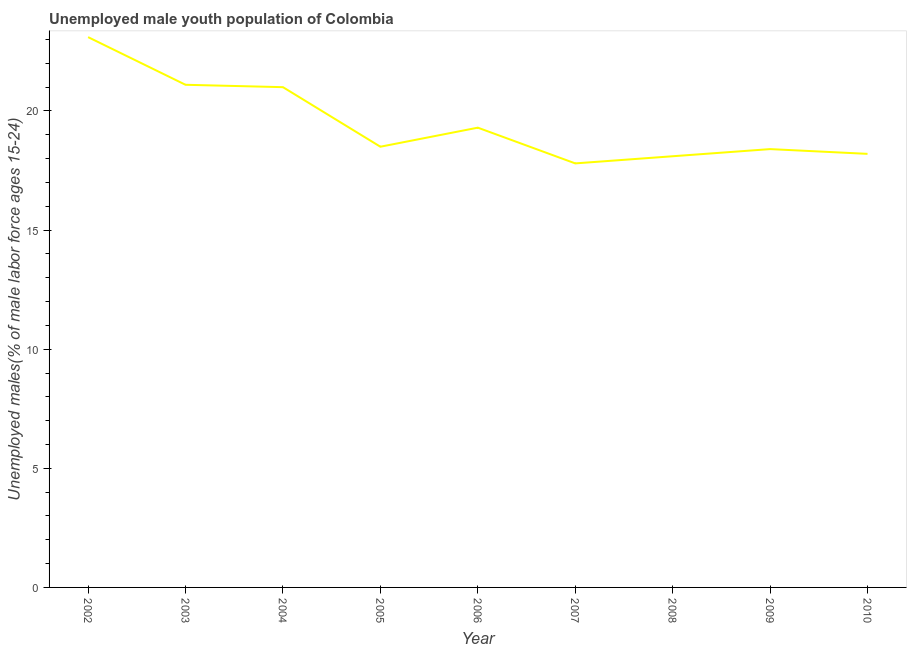What is the unemployed male youth in 2008?
Ensure brevity in your answer.  18.1. Across all years, what is the maximum unemployed male youth?
Provide a succinct answer. 23.1. Across all years, what is the minimum unemployed male youth?
Give a very brief answer. 17.8. In which year was the unemployed male youth maximum?
Make the answer very short. 2002. In which year was the unemployed male youth minimum?
Your answer should be compact. 2007. What is the sum of the unemployed male youth?
Provide a succinct answer. 175.5. What is the difference between the unemployed male youth in 2002 and 2003?
Your answer should be compact. 2. What is the average unemployed male youth per year?
Keep it short and to the point. 19.5. Do a majority of the years between 2006 and 2005 (inclusive) have unemployed male youth greater than 15 %?
Offer a terse response. No. What is the ratio of the unemployed male youth in 2003 to that in 2008?
Give a very brief answer. 1.17. Is the unemployed male youth in 2002 less than that in 2008?
Keep it short and to the point. No. What is the difference between the highest and the second highest unemployed male youth?
Ensure brevity in your answer.  2. What is the difference between the highest and the lowest unemployed male youth?
Provide a succinct answer. 5.3. Does the unemployed male youth monotonically increase over the years?
Your response must be concise. No. How many lines are there?
Give a very brief answer. 1. How many years are there in the graph?
Make the answer very short. 9. Are the values on the major ticks of Y-axis written in scientific E-notation?
Your answer should be very brief. No. Does the graph contain grids?
Your answer should be compact. No. What is the title of the graph?
Your response must be concise. Unemployed male youth population of Colombia. What is the label or title of the Y-axis?
Provide a short and direct response. Unemployed males(% of male labor force ages 15-24). What is the Unemployed males(% of male labor force ages 15-24) in 2002?
Provide a short and direct response. 23.1. What is the Unemployed males(% of male labor force ages 15-24) in 2003?
Offer a very short reply. 21.1. What is the Unemployed males(% of male labor force ages 15-24) of 2004?
Make the answer very short. 21. What is the Unemployed males(% of male labor force ages 15-24) of 2006?
Your answer should be very brief. 19.3. What is the Unemployed males(% of male labor force ages 15-24) of 2007?
Keep it short and to the point. 17.8. What is the Unemployed males(% of male labor force ages 15-24) in 2008?
Offer a terse response. 18.1. What is the Unemployed males(% of male labor force ages 15-24) of 2009?
Provide a succinct answer. 18.4. What is the Unemployed males(% of male labor force ages 15-24) of 2010?
Provide a succinct answer. 18.2. What is the difference between the Unemployed males(% of male labor force ages 15-24) in 2002 and 2004?
Keep it short and to the point. 2.1. What is the difference between the Unemployed males(% of male labor force ages 15-24) in 2002 and 2005?
Your answer should be very brief. 4.6. What is the difference between the Unemployed males(% of male labor force ages 15-24) in 2002 and 2007?
Your answer should be very brief. 5.3. What is the difference between the Unemployed males(% of male labor force ages 15-24) in 2002 and 2010?
Give a very brief answer. 4.9. What is the difference between the Unemployed males(% of male labor force ages 15-24) in 2003 and 2004?
Keep it short and to the point. 0.1. What is the difference between the Unemployed males(% of male labor force ages 15-24) in 2003 and 2005?
Ensure brevity in your answer.  2.6. What is the difference between the Unemployed males(% of male labor force ages 15-24) in 2003 and 2007?
Your response must be concise. 3.3. What is the difference between the Unemployed males(% of male labor force ages 15-24) in 2003 and 2009?
Your answer should be compact. 2.7. What is the difference between the Unemployed males(% of male labor force ages 15-24) in 2003 and 2010?
Offer a very short reply. 2.9. What is the difference between the Unemployed males(% of male labor force ages 15-24) in 2004 and 2005?
Offer a very short reply. 2.5. What is the difference between the Unemployed males(% of male labor force ages 15-24) in 2004 and 2006?
Your answer should be very brief. 1.7. What is the difference between the Unemployed males(% of male labor force ages 15-24) in 2004 and 2008?
Keep it short and to the point. 2.9. What is the difference between the Unemployed males(% of male labor force ages 15-24) in 2006 and 2009?
Provide a short and direct response. 0.9. What is the difference between the Unemployed males(% of male labor force ages 15-24) in 2007 and 2009?
Offer a very short reply. -0.6. What is the difference between the Unemployed males(% of male labor force ages 15-24) in 2008 and 2010?
Your response must be concise. -0.1. What is the difference between the Unemployed males(% of male labor force ages 15-24) in 2009 and 2010?
Your answer should be compact. 0.2. What is the ratio of the Unemployed males(% of male labor force ages 15-24) in 2002 to that in 2003?
Your answer should be very brief. 1.09. What is the ratio of the Unemployed males(% of male labor force ages 15-24) in 2002 to that in 2004?
Provide a succinct answer. 1.1. What is the ratio of the Unemployed males(% of male labor force ages 15-24) in 2002 to that in 2005?
Provide a succinct answer. 1.25. What is the ratio of the Unemployed males(% of male labor force ages 15-24) in 2002 to that in 2006?
Provide a short and direct response. 1.2. What is the ratio of the Unemployed males(% of male labor force ages 15-24) in 2002 to that in 2007?
Offer a terse response. 1.3. What is the ratio of the Unemployed males(% of male labor force ages 15-24) in 2002 to that in 2008?
Your answer should be very brief. 1.28. What is the ratio of the Unemployed males(% of male labor force ages 15-24) in 2002 to that in 2009?
Ensure brevity in your answer.  1.25. What is the ratio of the Unemployed males(% of male labor force ages 15-24) in 2002 to that in 2010?
Your answer should be compact. 1.27. What is the ratio of the Unemployed males(% of male labor force ages 15-24) in 2003 to that in 2004?
Keep it short and to the point. 1. What is the ratio of the Unemployed males(% of male labor force ages 15-24) in 2003 to that in 2005?
Keep it short and to the point. 1.14. What is the ratio of the Unemployed males(% of male labor force ages 15-24) in 2003 to that in 2006?
Your response must be concise. 1.09. What is the ratio of the Unemployed males(% of male labor force ages 15-24) in 2003 to that in 2007?
Offer a very short reply. 1.19. What is the ratio of the Unemployed males(% of male labor force ages 15-24) in 2003 to that in 2008?
Give a very brief answer. 1.17. What is the ratio of the Unemployed males(% of male labor force ages 15-24) in 2003 to that in 2009?
Give a very brief answer. 1.15. What is the ratio of the Unemployed males(% of male labor force ages 15-24) in 2003 to that in 2010?
Your response must be concise. 1.16. What is the ratio of the Unemployed males(% of male labor force ages 15-24) in 2004 to that in 2005?
Offer a terse response. 1.14. What is the ratio of the Unemployed males(% of male labor force ages 15-24) in 2004 to that in 2006?
Offer a terse response. 1.09. What is the ratio of the Unemployed males(% of male labor force ages 15-24) in 2004 to that in 2007?
Keep it short and to the point. 1.18. What is the ratio of the Unemployed males(% of male labor force ages 15-24) in 2004 to that in 2008?
Offer a terse response. 1.16. What is the ratio of the Unemployed males(% of male labor force ages 15-24) in 2004 to that in 2009?
Provide a short and direct response. 1.14. What is the ratio of the Unemployed males(% of male labor force ages 15-24) in 2004 to that in 2010?
Offer a very short reply. 1.15. What is the ratio of the Unemployed males(% of male labor force ages 15-24) in 2005 to that in 2007?
Provide a short and direct response. 1.04. What is the ratio of the Unemployed males(% of male labor force ages 15-24) in 2005 to that in 2008?
Offer a terse response. 1.02. What is the ratio of the Unemployed males(% of male labor force ages 15-24) in 2005 to that in 2010?
Your response must be concise. 1.02. What is the ratio of the Unemployed males(% of male labor force ages 15-24) in 2006 to that in 2007?
Make the answer very short. 1.08. What is the ratio of the Unemployed males(% of male labor force ages 15-24) in 2006 to that in 2008?
Offer a very short reply. 1.07. What is the ratio of the Unemployed males(% of male labor force ages 15-24) in 2006 to that in 2009?
Offer a terse response. 1.05. What is the ratio of the Unemployed males(% of male labor force ages 15-24) in 2006 to that in 2010?
Your response must be concise. 1.06. What is the ratio of the Unemployed males(% of male labor force ages 15-24) in 2007 to that in 2008?
Provide a short and direct response. 0.98. What is the ratio of the Unemployed males(% of male labor force ages 15-24) in 2007 to that in 2010?
Provide a short and direct response. 0.98. What is the ratio of the Unemployed males(% of male labor force ages 15-24) in 2008 to that in 2009?
Offer a very short reply. 0.98. What is the ratio of the Unemployed males(% of male labor force ages 15-24) in 2008 to that in 2010?
Your answer should be very brief. 0.99. What is the ratio of the Unemployed males(% of male labor force ages 15-24) in 2009 to that in 2010?
Give a very brief answer. 1.01. 